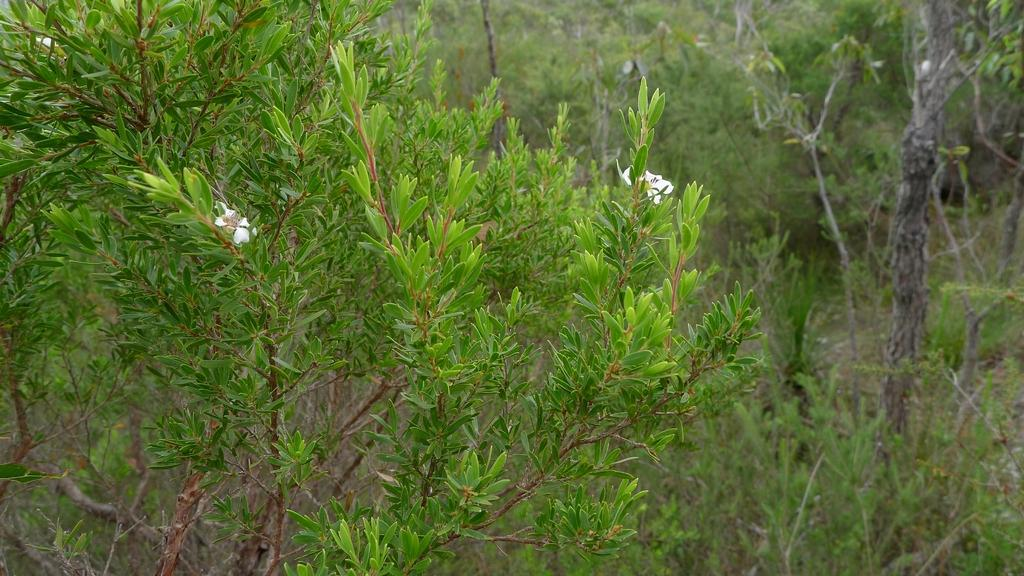What type of vegetation can be seen in the image? There are many plants and trees in the image. Are there any specific features of the plants in the image? Yes, there are white color flowers on the plants. What type of soda is being advertised on the kitty's collar in the image? There is no kitty or soda present in the image; it features plants and trees with white flowers. 